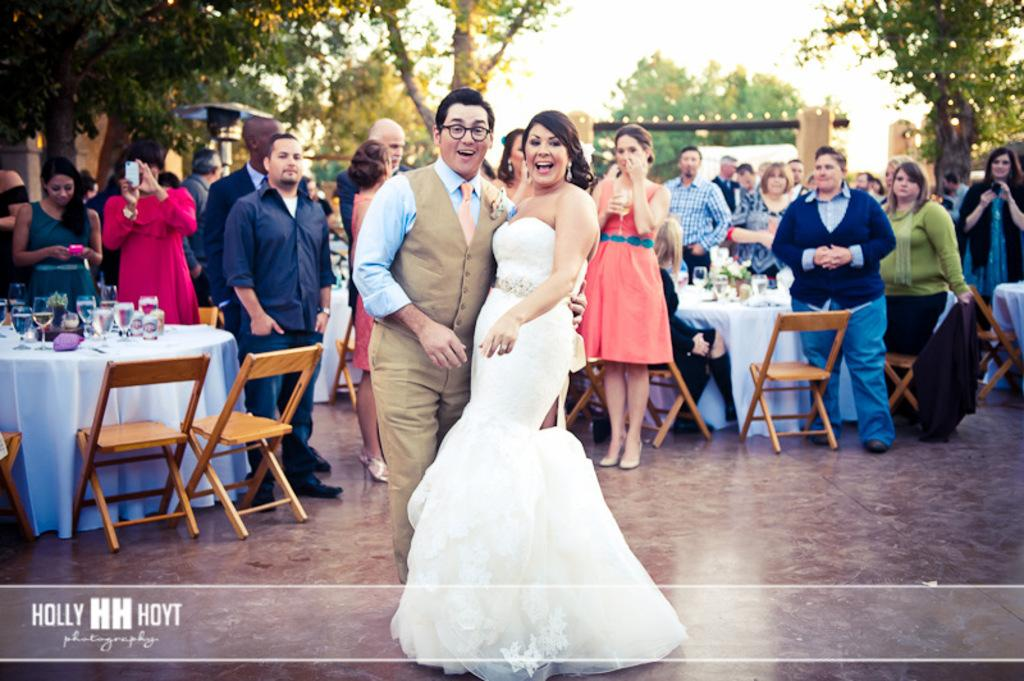How many persons are present in the image? There are persons standing in the image. What are two of the persons doing? Two of the persons are giving stills. What type of furniture is present in the image? There are chairs and a table in the image. What objects can be seen on the table? There are glasses on the table. What can be seen in the background of the image? There are trees visible in the distance. What type of rake is being used by one of the persons in the image? There is no rake present in the image; the persons are giving stills. How many beetles can be seen crawling on the table in the image? There are no beetles present in the image; only glasses can be seen on the table. 